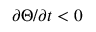<formula> <loc_0><loc_0><loc_500><loc_500>\partial \Theta / \partial t < 0</formula> 